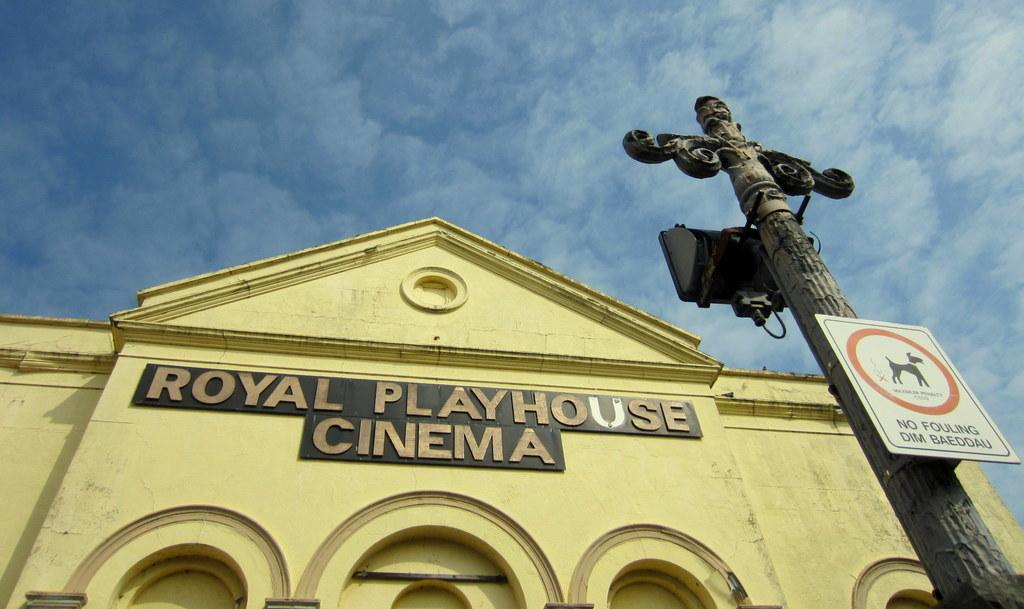<image>
Provide a brief description of the given image. The sign for the Royal Playhouse Cinema is in black and gold. 